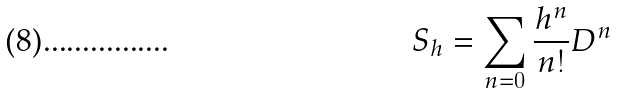Convert formula to latex. <formula><loc_0><loc_0><loc_500><loc_500>S _ { h } = \sum _ { n = 0 } \frac { h ^ { n } } { n ! } D ^ { n }</formula> 